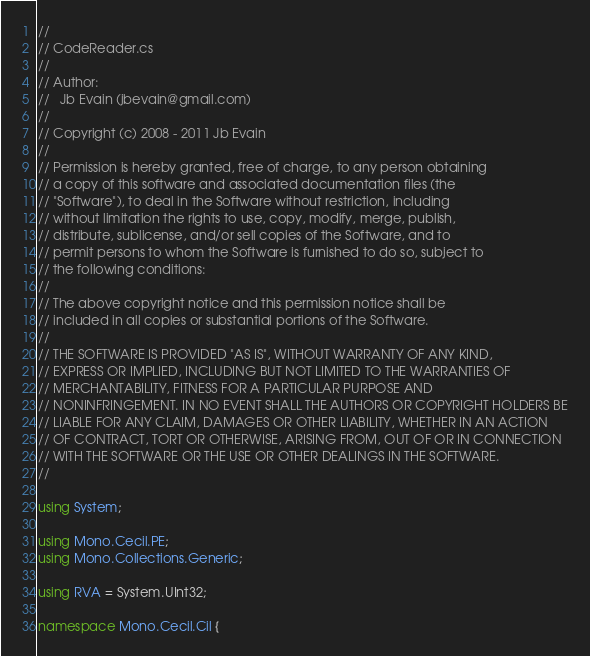Convert code to text. <code><loc_0><loc_0><loc_500><loc_500><_C#_>//
// CodeReader.cs
//
// Author:
//   Jb Evain (jbevain@gmail.com)
//
// Copyright (c) 2008 - 2011 Jb Evain
//
// Permission is hereby granted, free of charge, to any person obtaining
// a copy of this software and associated documentation files (the
// "Software"), to deal in the Software without restriction, including
// without limitation the rights to use, copy, modify, merge, publish,
// distribute, sublicense, and/or sell copies of the Software, and to
// permit persons to whom the Software is furnished to do so, subject to
// the following conditions:
//
// The above copyright notice and this permission notice shall be
// included in all copies or substantial portions of the Software.
//
// THE SOFTWARE IS PROVIDED "AS IS", WITHOUT WARRANTY OF ANY KIND,
// EXPRESS OR IMPLIED, INCLUDING BUT NOT LIMITED TO THE WARRANTIES OF
// MERCHANTABILITY, FITNESS FOR A PARTICULAR PURPOSE AND
// NONINFRINGEMENT. IN NO EVENT SHALL THE AUTHORS OR COPYRIGHT HOLDERS BE
// LIABLE FOR ANY CLAIM, DAMAGES OR OTHER LIABILITY, WHETHER IN AN ACTION
// OF CONTRACT, TORT OR OTHERWISE, ARISING FROM, OUT OF OR IN CONNECTION
// WITH THE SOFTWARE OR THE USE OR OTHER DEALINGS IN THE SOFTWARE.
//

using System;

using Mono.Cecil.PE;
using Mono.Collections.Generic;

using RVA = System.UInt32;

namespace Mono.Cecil.Cil {
</code> 